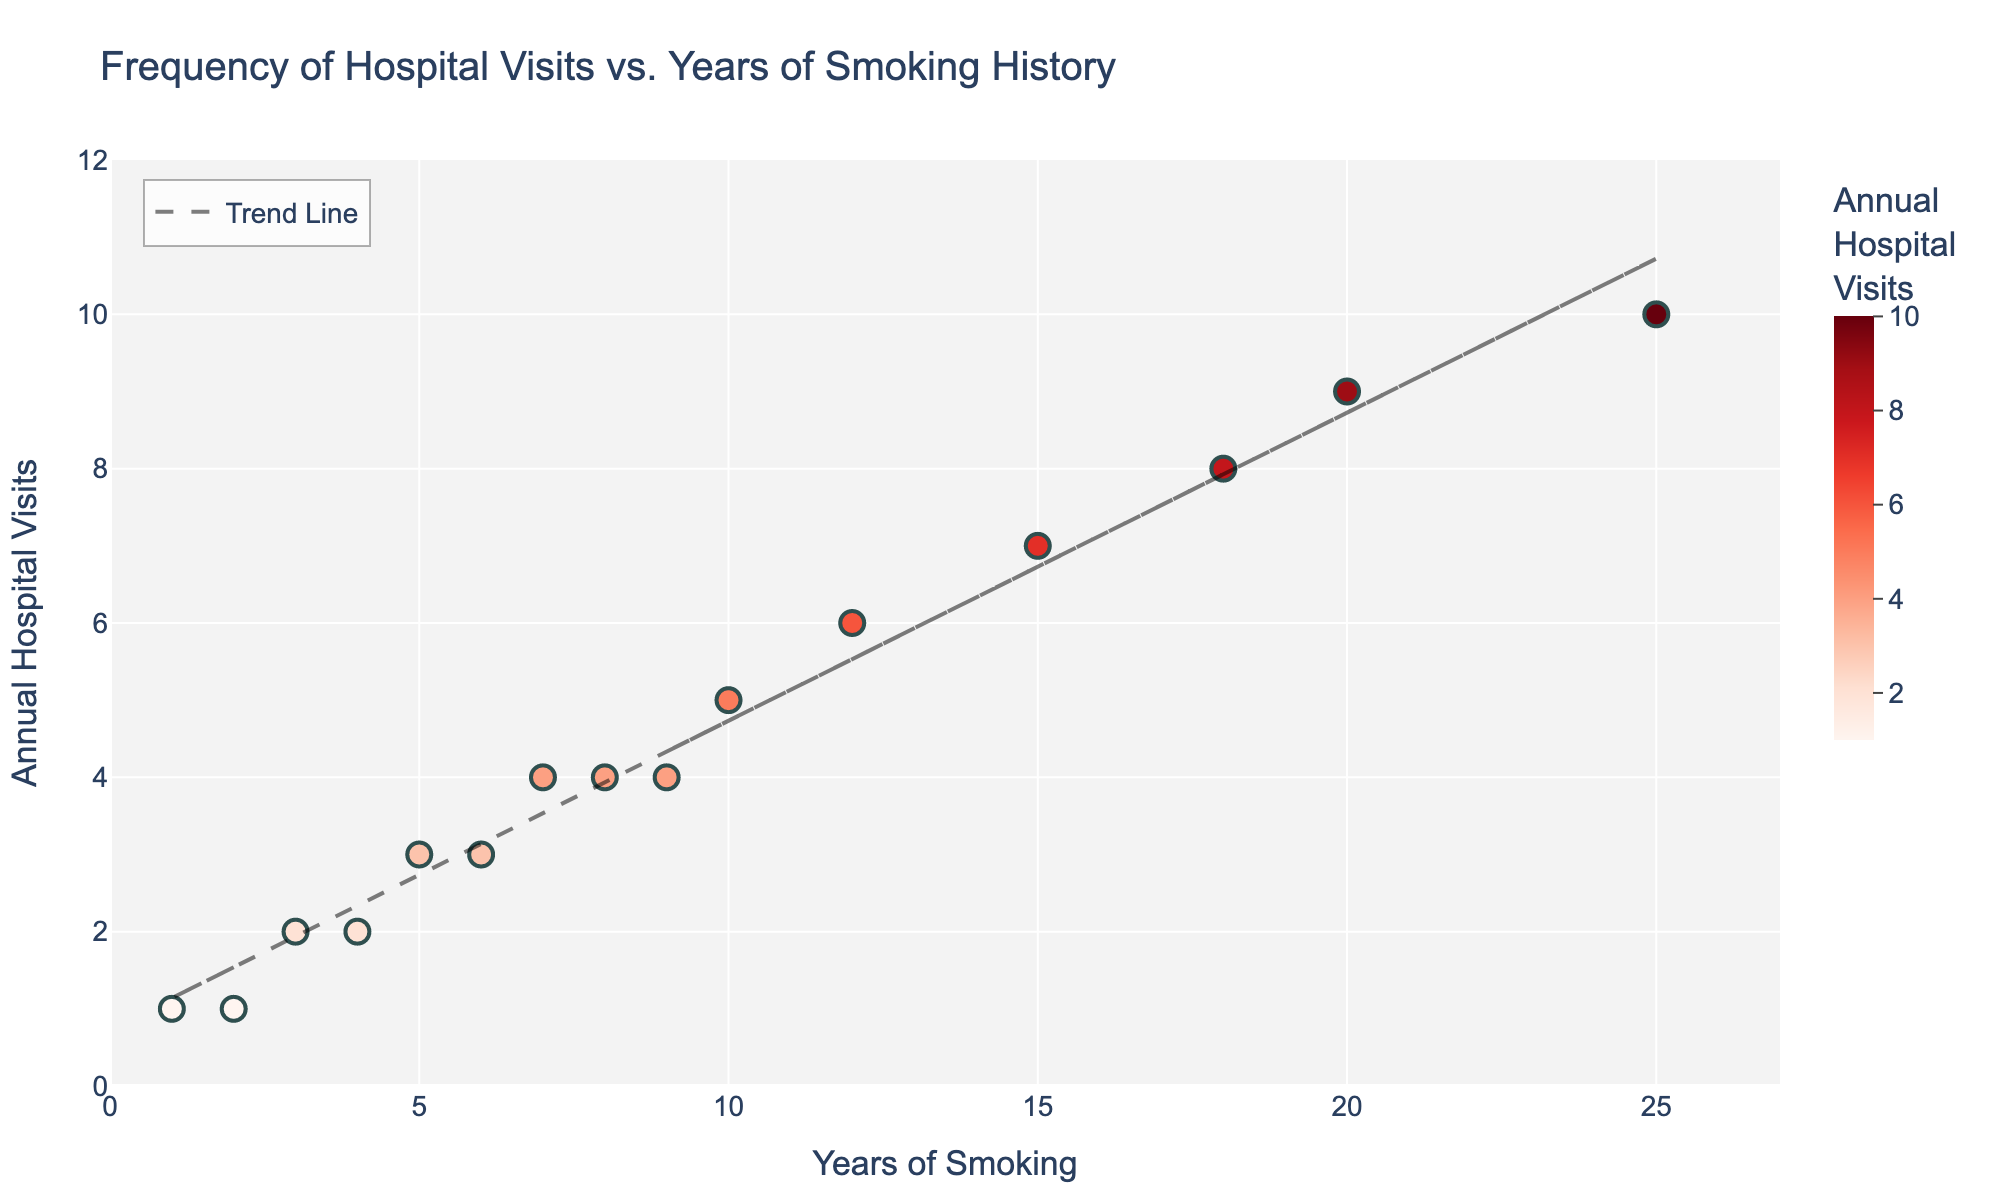How many data points are there in the plot? The plot shows data points that represent individual patients' years of smoking and their annual hospital visits. By counting the points, we can determine there are 15 data points in the scatter plot.
Answer: 15 What are the axis labels? The x-axis and y-axis labels help in identifying what data is being represented. The x-axis is labeled "Years of Smoking," and the y-axis is labeled "Annual Hospital Visits."
Answer: Years of Smoking, Annual Hospital Visits Which data point corresponds to the highest number of annual hospital visits? By examining the y-axis and locating the highest point on the plot, we find that the data point with the highest number of annual hospital visits is at 25 years of smoking, corresponding to 10 visits.
Answer: 25 years of smoking Is there a positive correlation between years of smoking and the frequency of hospital visits? A positive correlation exists if the trend line slopes upwards. In the plot, the trend line shows an upward slope, indicating that more years of smoking generally lead to more frequent hospital visits.
Answer: Yes Between how many annual hospital visits does the trend line cross at 10 years of smoking? To determine where the trend line intersects at 10 years of smoking, we find the point on the trend line directly above 10 on the x-axis. This corresponds to approximately 5 annual hospital visits.
Answer: 5 visits What is the difference in annual hospital visits between patients who have smoked for 20 years and those who have smoked for 10 years? By observing the scatter plot, we see that the point for 20 years of smoking has 9 visits, and for 10 years of smoking, it has 5 visits. The difference is 9 visits - 5 visits = 4 visits.
Answer: 4 visits Which patient has the least number of annual hospital visits with less than 5 years of smoking history? We will look at the data points with less than 5 years of smoking history and identify the lowest point. The patient with 1 year of smoking history has the least number of visits, which is 1 visit.
Answer: Patient with 1 year of smoking How does the scatter plot indicate variance in the annual hospital visits among patients with similar years of smoking history? The scatter plot shows variability by the spread of data points at certain years of smoking. For example, patients with 7 years of smoking have different visit numbers ranging around 4 visits, showing variability.
Answer: Variance exists as seen from the spread at years like 7 and 12 What can you infer about the trend in hospital visits for patients who have smoked for over 15 years? Observing the data points and trend line for patients with over 15 years of smoking, most points are high on the y-axis, indicating higher hospital visit frequency.
Answer: More hospital visits 